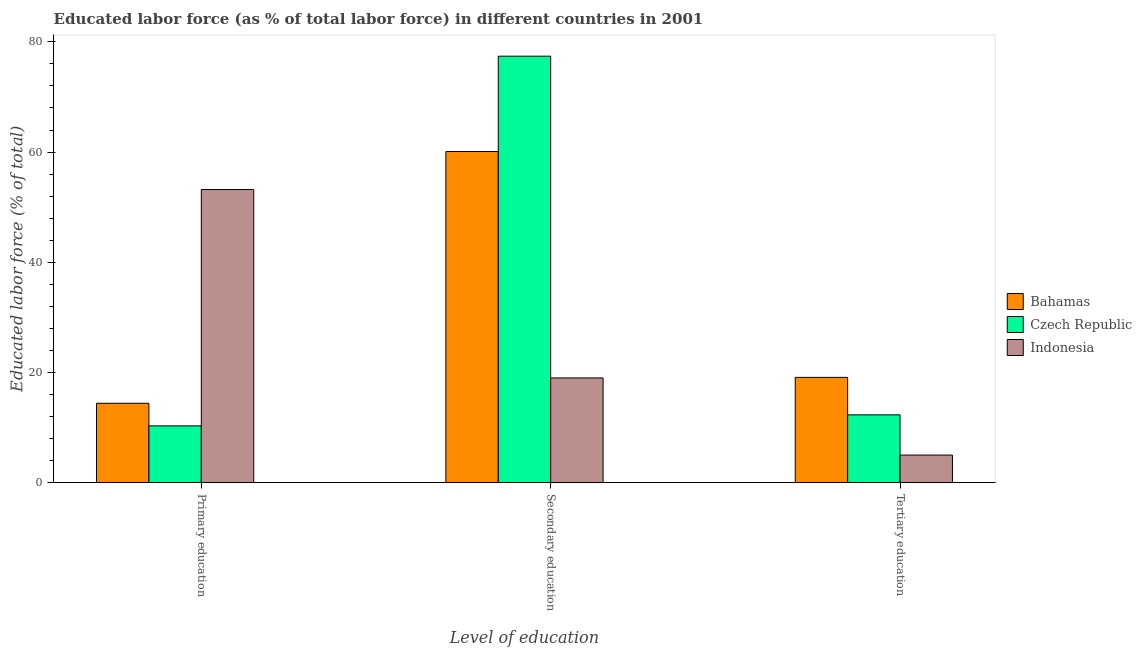How many different coloured bars are there?
Your answer should be very brief. 3. Are the number of bars per tick equal to the number of legend labels?
Your answer should be very brief. Yes. What is the percentage of labor force who received secondary education in Czech Republic?
Provide a succinct answer. 77.4. Across all countries, what is the maximum percentage of labor force who received tertiary education?
Offer a very short reply. 19.1. In which country was the percentage of labor force who received tertiary education maximum?
Your response must be concise. Bahamas. What is the total percentage of labor force who received primary education in the graph?
Offer a very short reply. 77.9. What is the difference between the percentage of labor force who received tertiary education in Bahamas and that in Indonesia?
Your response must be concise. 14.1. What is the difference between the percentage of labor force who received secondary education in Czech Republic and the percentage of labor force who received primary education in Indonesia?
Provide a succinct answer. 24.2. What is the average percentage of labor force who received primary education per country?
Offer a very short reply. 25.97. What is the difference between the percentage of labor force who received tertiary education and percentage of labor force who received secondary education in Indonesia?
Your answer should be compact. -14. In how many countries, is the percentage of labor force who received tertiary education greater than 20 %?
Your answer should be compact. 0. What is the ratio of the percentage of labor force who received primary education in Indonesia to that in Czech Republic?
Offer a very short reply. 5.17. What is the difference between the highest and the second highest percentage of labor force who received primary education?
Keep it short and to the point. 38.8. What is the difference between the highest and the lowest percentage of labor force who received tertiary education?
Ensure brevity in your answer.  14.1. What does the 2nd bar from the left in Secondary education represents?
Your response must be concise. Czech Republic. What does the 1st bar from the right in Secondary education represents?
Your response must be concise. Indonesia. Are all the bars in the graph horizontal?
Give a very brief answer. No. How many countries are there in the graph?
Ensure brevity in your answer.  3. Does the graph contain any zero values?
Provide a short and direct response. No. Where does the legend appear in the graph?
Make the answer very short. Center right. What is the title of the graph?
Keep it short and to the point. Educated labor force (as % of total labor force) in different countries in 2001. What is the label or title of the X-axis?
Offer a terse response. Level of education. What is the label or title of the Y-axis?
Provide a short and direct response. Educated labor force (% of total). What is the Educated labor force (% of total) in Bahamas in Primary education?
Provide a short and direct response. 14.4. What is the Educated labor force (% of total) in Czech Republic in Primary education?
Keep it short and to the point. 10.3. What is the Educated labor force (% of total) of Indonesia in Primary education?
Your answer should be very brief. 53.2. What is the Educated labor force (% of total) of Bahamas in Secondary education?
Your answer should be compact. 60.1. What is the Educated labor force (% of total) in Czech Republic in Secondary education?
Your response must be concise. 77.4. What is the Educated labor force (% of total) of Indonesia in Secondary education?
Make the answer very short. 19. What is the Educated labor force (% of total) in Bahamas in Tertiary education?
Your answer should be compact. 19.1. What is the Educated labor force (% of total) of Czech Republic in Tertiary education?
Your response must be concise. 12.3. What is the Educated labor force (% of total) of Indonesia in Tertiary education?
Your response must be concise. 5. Across all Level of education, what is the maximum Educated labor force (% of total) in Bahamas?
Ensure brevity in your answer.  60.1. Across all Level of education, what is the maximum Educated labor force (% of total) of Czech Republic?
Your response must be concise. 77.4. Across all Level of education, what is the maximum Educated labor force (% of total) in Indonesia?
Your answer should be very brief. 53.2. Across all Level of education, what is the minimum Educated labor force (% of total) of Bahamas?
Offer a very short reply. 14.4. Across all Level of education, what is the minimum Educated labor force (% of total) of Czech Republic?
Make the answer very short. 10.3. Across all Level of education, what is the minimum Educated labor force (% of total) of Indonesia?
Your response must be concise. 5. What is the total Educated labor force (% of total) in Bahamas in the graph?
Give a very brief answer. 93.6. What is the total Educated labor force (% of total) of Czech Republic in the graph?
Provide a short and direct response. 100. What is the total Educated labor force (% of total) in Indonesia in the graph?
Provide a succinct answer. 77.2. What is the difference between the Educated labor force (% of total) in Bahamas in Primary education and that in Secondary education?
Your response must be concise. -45.7. What is the difference between the Educated labor force (% of total) of Czech Republic in Primary education and that in Secondary education?
Provide a succinct answer. -67.1. What is the difference between the Educated labor force (% of total) in Indonesia in Primary education and that in Secondary education?
Offer a very short reply. 34.2. What is the difference between the Educated labor force (% of total) of Czech Republic in Primary education and that in Tertiary education?
Keep it short and to the point. -2. What is the difference between the Educated labor force (% of total) in Indonesia in Primary education and that in Tertiary education?
Your response must be concise. 48.2. What is the difference between the Educated labor force (% of total) in Bahamas in Secondary education and that in Tertiary education?
Ensure brevity in your answer.  41. What is the difference between the Educated labor force (% of total) in Czech Republic in Secondary education and that in Tertiary education?
Offer a terse response. 65.1. What is the difference between the Educated labor force (% of total) of Indonesia in Secondary education and that in Tertiary education?
Keep it short and to the point. 14. What is the difference between the Educated labor force (% of total) in Bahamas in Primary education and the Educated labor force (% of total) in Czech Republic in Secondary education?
Ensure brevity in your answer.  -63. What is the difference between the Educated labor force (% of total) in Czech Republic in Primary education and the Educated labor force (% of total) in Indonesia in Secondary education?
Provide a succinct answer. -8.7. What is the difference between the Educated labor force (% of total) in Bahamas in Primary education and the Educated labor force (% of total) in Indonesia in Tertiary education?
Keep it short and to the point. 9.4. What is the difference between the Educated labor force (% of total) of Czech Republic in Primary education and the Educated labor force (% of total) of Indonesia in Tertiary education?
Provide a short and direct response. 5.3. What is the difference between the Educated labor force (% of total) in Bahamas in Secondary education and the Educated labor force (% of total) in Czech Republic in Tertiary education?
Give a very brief answer. 47.8. What is the difference between the Educated labor force (% of total) of Bahamas in Secondary education and the Educated labor force (% of total) of Indonesia in Tertiary education?
Provide a succinct answer. 55.1. What is the difference between the Educated labor force (% of total) in Czech Republic in Secondary education and the Educated labor force (% of total) in Indonesia in Tertiary education?
Ensure brevity in your answer.  72.4. What is the average Educated labor force (% of total) in Bahamas per Level of education?
Make the answer very short. 31.2. What is the average Educated labor force (% of total) in Czech Republic per Level of education?
Offer a very short reply. 33.33. What is the average Educated labor force (% of total) of Indonesia per Level of education?
Keep it short and to the point. 25.73. What is the difference between the Educated labor force (% of total) of Bahamas and Educated labor force (% of total) of Czech Republic in Primary education?
Offer a terse response. 4.1. What is the difference between the Educated labor force (% of total) in Bahamas and Educated labor force (% of total) in Indonesia in Primary education?
Your answer should be very brief. -38.8. What is the difference between the Educated labor force (% of total) of Czech Republic and Educated labor force (% of total) of Indonesia in Primary education?
Provide a succinct answer. -42.9. What is the difference between the Educated labor force (% of total) in Bahamas and Educated labor force (% of total) in Czech Republic in Secondary education?
Give a very brief answer. -17.3. What is the difference between the Educated labor force (% of total) of Bahamas and Educated labor force (% of total) of Indonesia in Secondary education?
Offer a terse response. 41.1. What is the difference between the Educated labor force (% of total) in Czech Republic and Educated labor force (% of total) in Indonesia in Secondary education?
Keep it short and to the point. 58.4. What is the difference between the Educated labor force (% of total) in Bahamas and Educated labor force (% of total) in Indonesia in Tertiary education?
Your response must be concise. 14.1. What is the difference between the Educated labor force (% of total) in Czech Republic and Educated labor force (% of total) in Indonesia in Tertiary education?
Ensure brevity in your answer.  7.3. What is the ratio of the Educated labor force (% of total) in Bahamas in Primary education to that in Secondary education?
Ensure brevity in your answer.  0.24. What is the ratio of the Educated labor force (% of total) of Czech Republic in Primary education to that in Secondary education?
Your response must be concise. 0.13. What is the ratio of the Educated labor force (% of total) in Bahamas in Primary education to that in Tertiary education?
Your response must be concise. 0.75. What is the ratio of the Educated labor force (% of total) of Czech Republic in Primary education to that in Tertiary education?
Provide a succinct answer. 0.84. What is the ratio of the Educated labor force (% of total) in Indonesia in Primary education to that in Tertiary education?
Make the answer very short. 10.64. What is the ratio of the Educated labor force (% of total) of Bahamas in Secondary education to that in Tertiary education?
Your answer should be compact. 3.15. What is the ratio of the Educated labor force (% of total) in Czech Republic in Secondary education to that in Tertiary education?
Your answer should be compact. 6.29. What is the ratio of the Educated labor force (% of total) of Indonesia in Secondary education to that in Tertiary education?
Your answer should be very brief. 3.8. What is the difference between the highest and the second highest Educated labor force (% of total) in Czech Republic?
Your answer should be compact. 65.1. What is the difference between the highest and the second highest Educated labor force (% of total) of Indonesia?
Your answer should be very brief. 34.2. What is the difference between the highest and the lowest Educated labor force (% of total) of Bahamas?
Your response must be concise. 45.7. What is the difference between the highest and the lowest Educated labor force (% of total) in Czech Republic?
Your response must be concise. 67.1. What is the difference between the highest and the lowest Educated labor force (% of total) of Indonesia?
Offer a terse response. 48.2. 